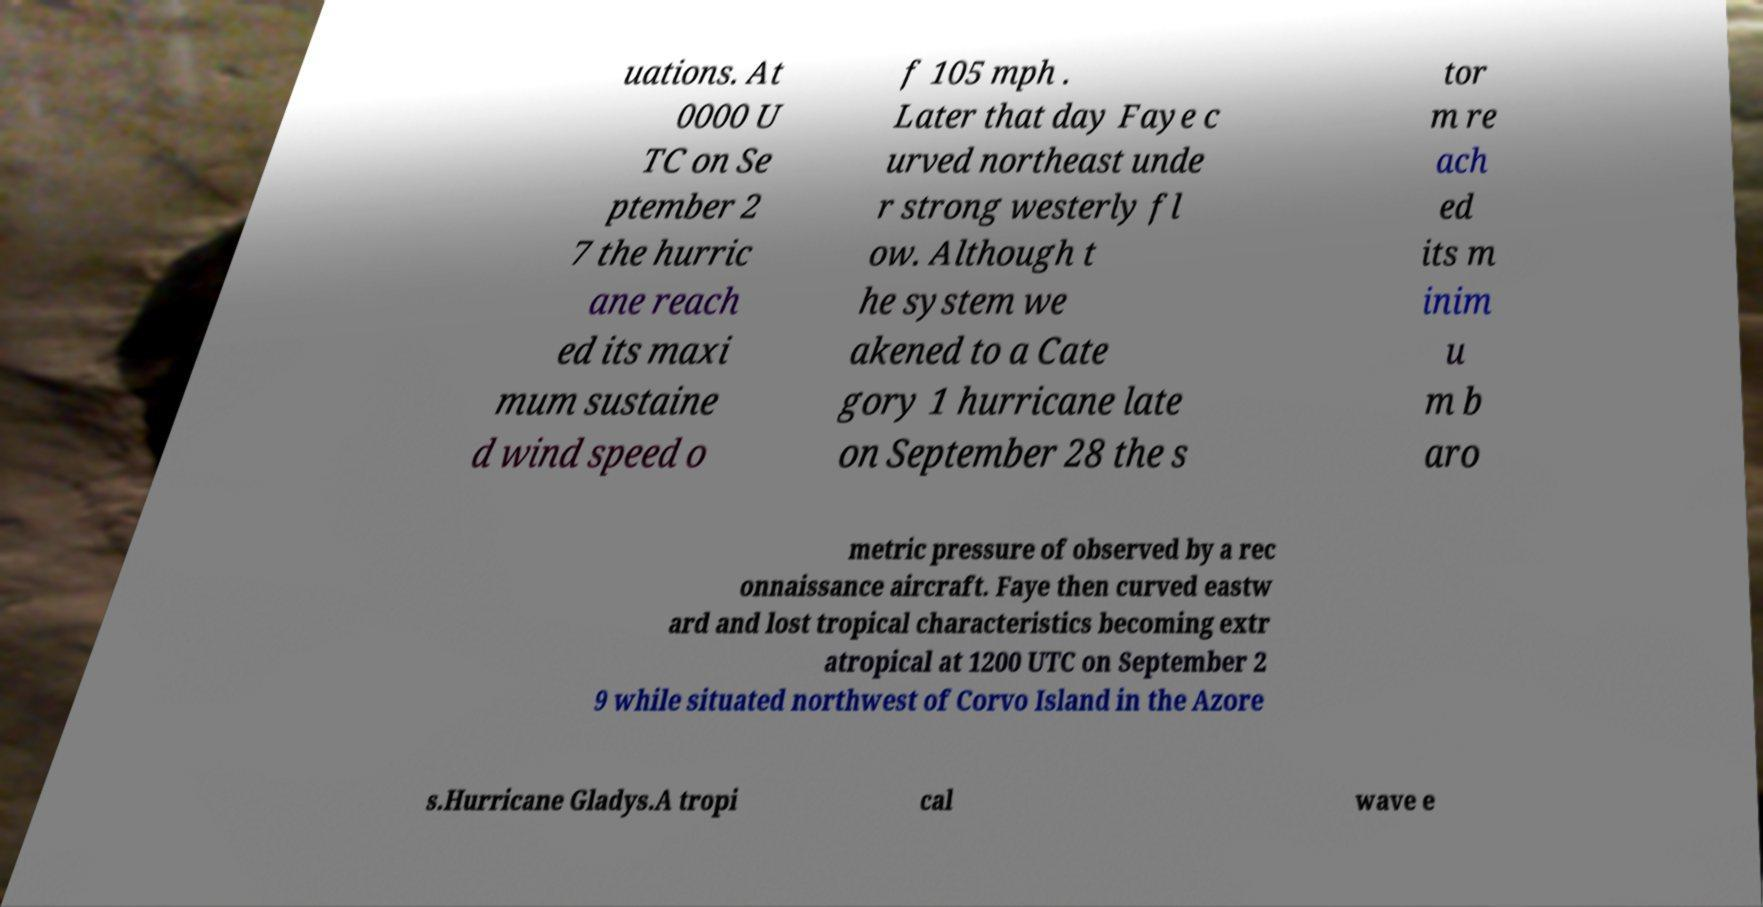Could you assist in decoding the text presented in this image and type it out clearly? uations. At 0000 U TC on Se ptember 2 7 the hurric ane reach ed its maxi mum sustaine d wind speed o f 105 mph . Later that day Faye c urved northeast unde r strong westerly fl ow. Although t he system we akened to a Cate gory 1 hurricane late on September 28 the s tor m re ach ed its m inim u m b aro metric pressure of observed by a rec onnaissance aircraft. Faye then curved eastw ard and lost tropical characteristics becoming extr atropical at 1200 UTC on September 2 9 while situated northwest of Corvo Island in the Azore s.Hurricane Gladys.A tropi cal wave e 